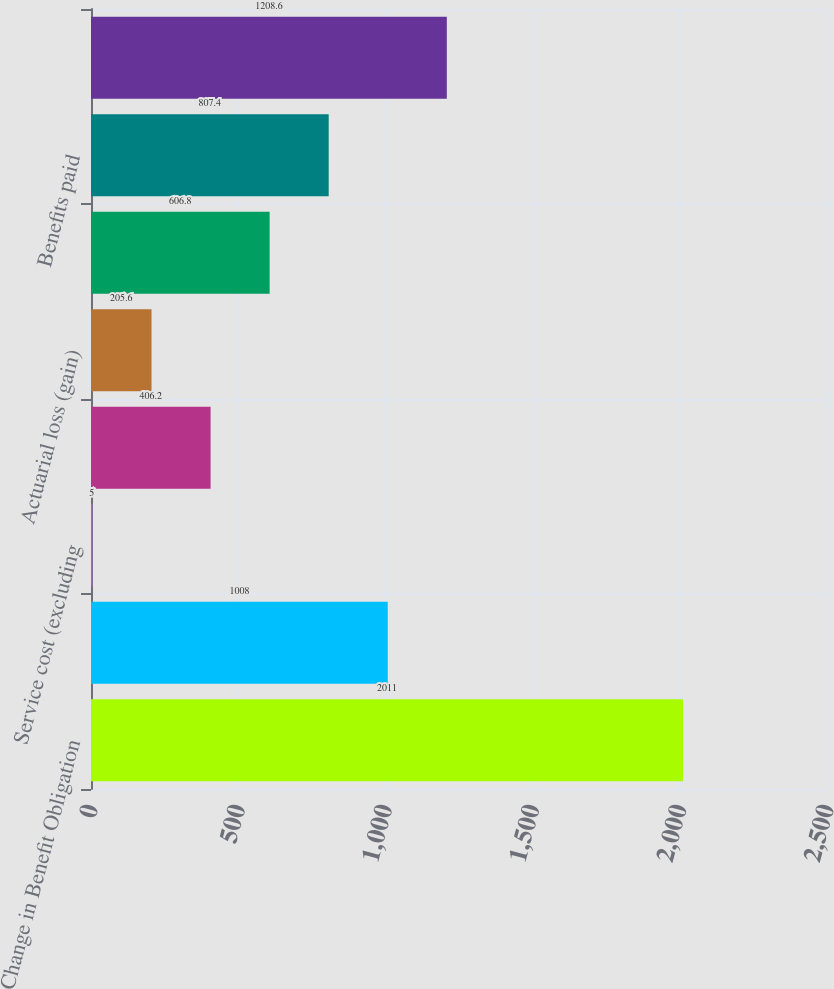<chart> <loc_0><loc_0><loc_500><loc_500><bar_chart><fcel>Change in Benefit Obligation<fcel>Benefit obligation - beginning<fcel>Service cost (excluding<fcel>Interest cost<fcel>Actuarial loss (gain)<fcel>Change in assumptions<fcel>Benefits paid<fcel>Benefit obligation - end of<nl><fcel>2011<fcel>1008<fcel>5<fcel>406.2<fcel>205.6<fcel>606.8<fcel>807.4<fcel>1208.6<nl></chart> 